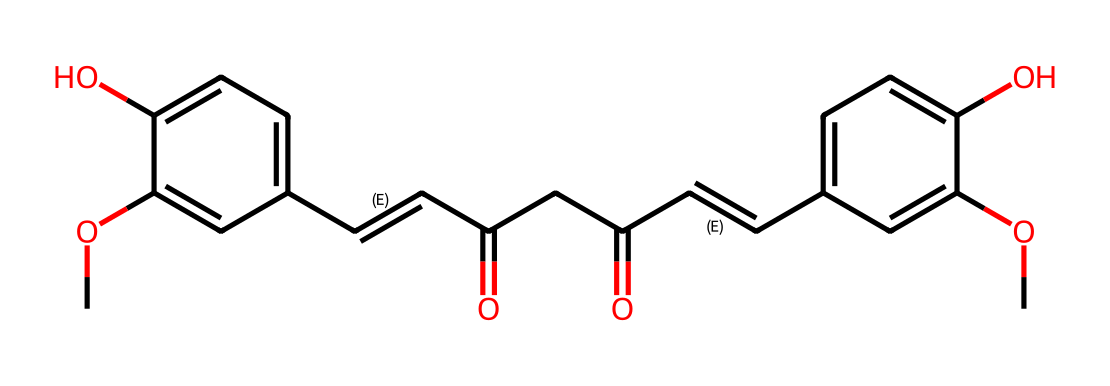What is the primary color associated with curcumin? The chemical structure of curcumin features a range of conjugated double bonds which absorb certain wavelengths of light, and the overall structure is known for its bright yellow color.
Answer: yellow How many carbon atoms are present in curcumin? To determine the number of carbon atoms, we can count each 'C' in the SMILES representation, both in the main structure and the substituents. There are 21 carbon atoms in total when we tally them.
Answer: 21 What functional groups are present in curcumin? By analyzing the chemical structure, we can identify several functional groups. The presence of hydroxyl (-OH) groups and contrasting carbonyl (=O) functional groups indicate that curcumin has phenolic and ketone functionalities.
Answer: hydroxyl and carbonyl What type of chemical structure does curcumin represent? Curcumin's structure contains a series of conjugated double bonds and carbonyl functionalities, allowing it to act as a dye, which is characterized by its vibrant color and ability to absorb visible light.
Answer: dye Does curcumin have any hydroxyl groups? By examining the chemical structure, we see distinct -OH groups that exhibit the characteristics of phenols. This indicates the presence of hydroxyl functional groups in curcumin.
Answer: yes What is the molecular formula of curcumin? Counting atoms from the SMILES representation reveals the molecular composition: C21H20O6. Each letter and the corresponding numbers indicate the number of each atom present in the molecular structure.
Answer: C21H20O6 